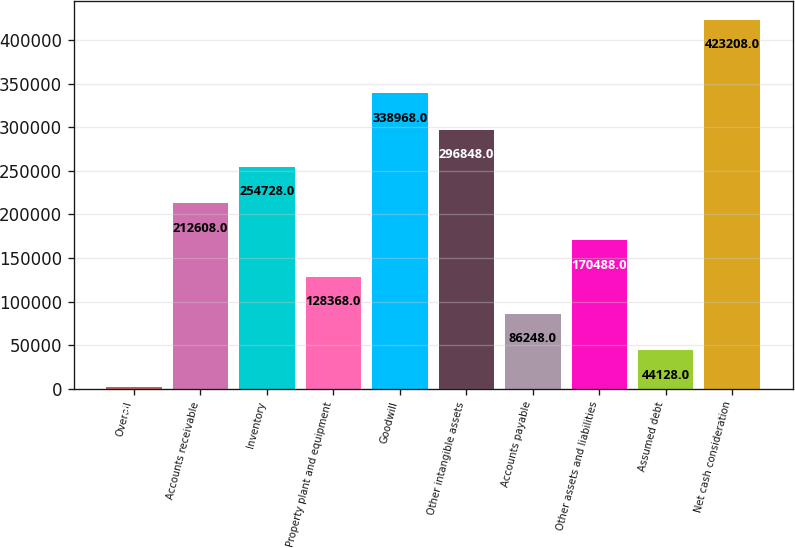<chart> <loc_0><loc_0><loc_500><loc_500><bar_chart><fcel>Overall<fcel>Accounts receivable<fcel>Inventory<fcel>Property plant and equipment<fcel>Goodwill<fcel>Other intangible assets<fcel>Accounts payable<fcel>Other assets and liabilities<fcel>Assumed debt<fcel>Net cash consideration<nl><fcel>2008<fcel>212608<fcel>254728<fcel>128368<fcel>338968<fcel>296848<fcel>86248<fcel>170488<fcel>44128<fcel>423208<nl></chart> 